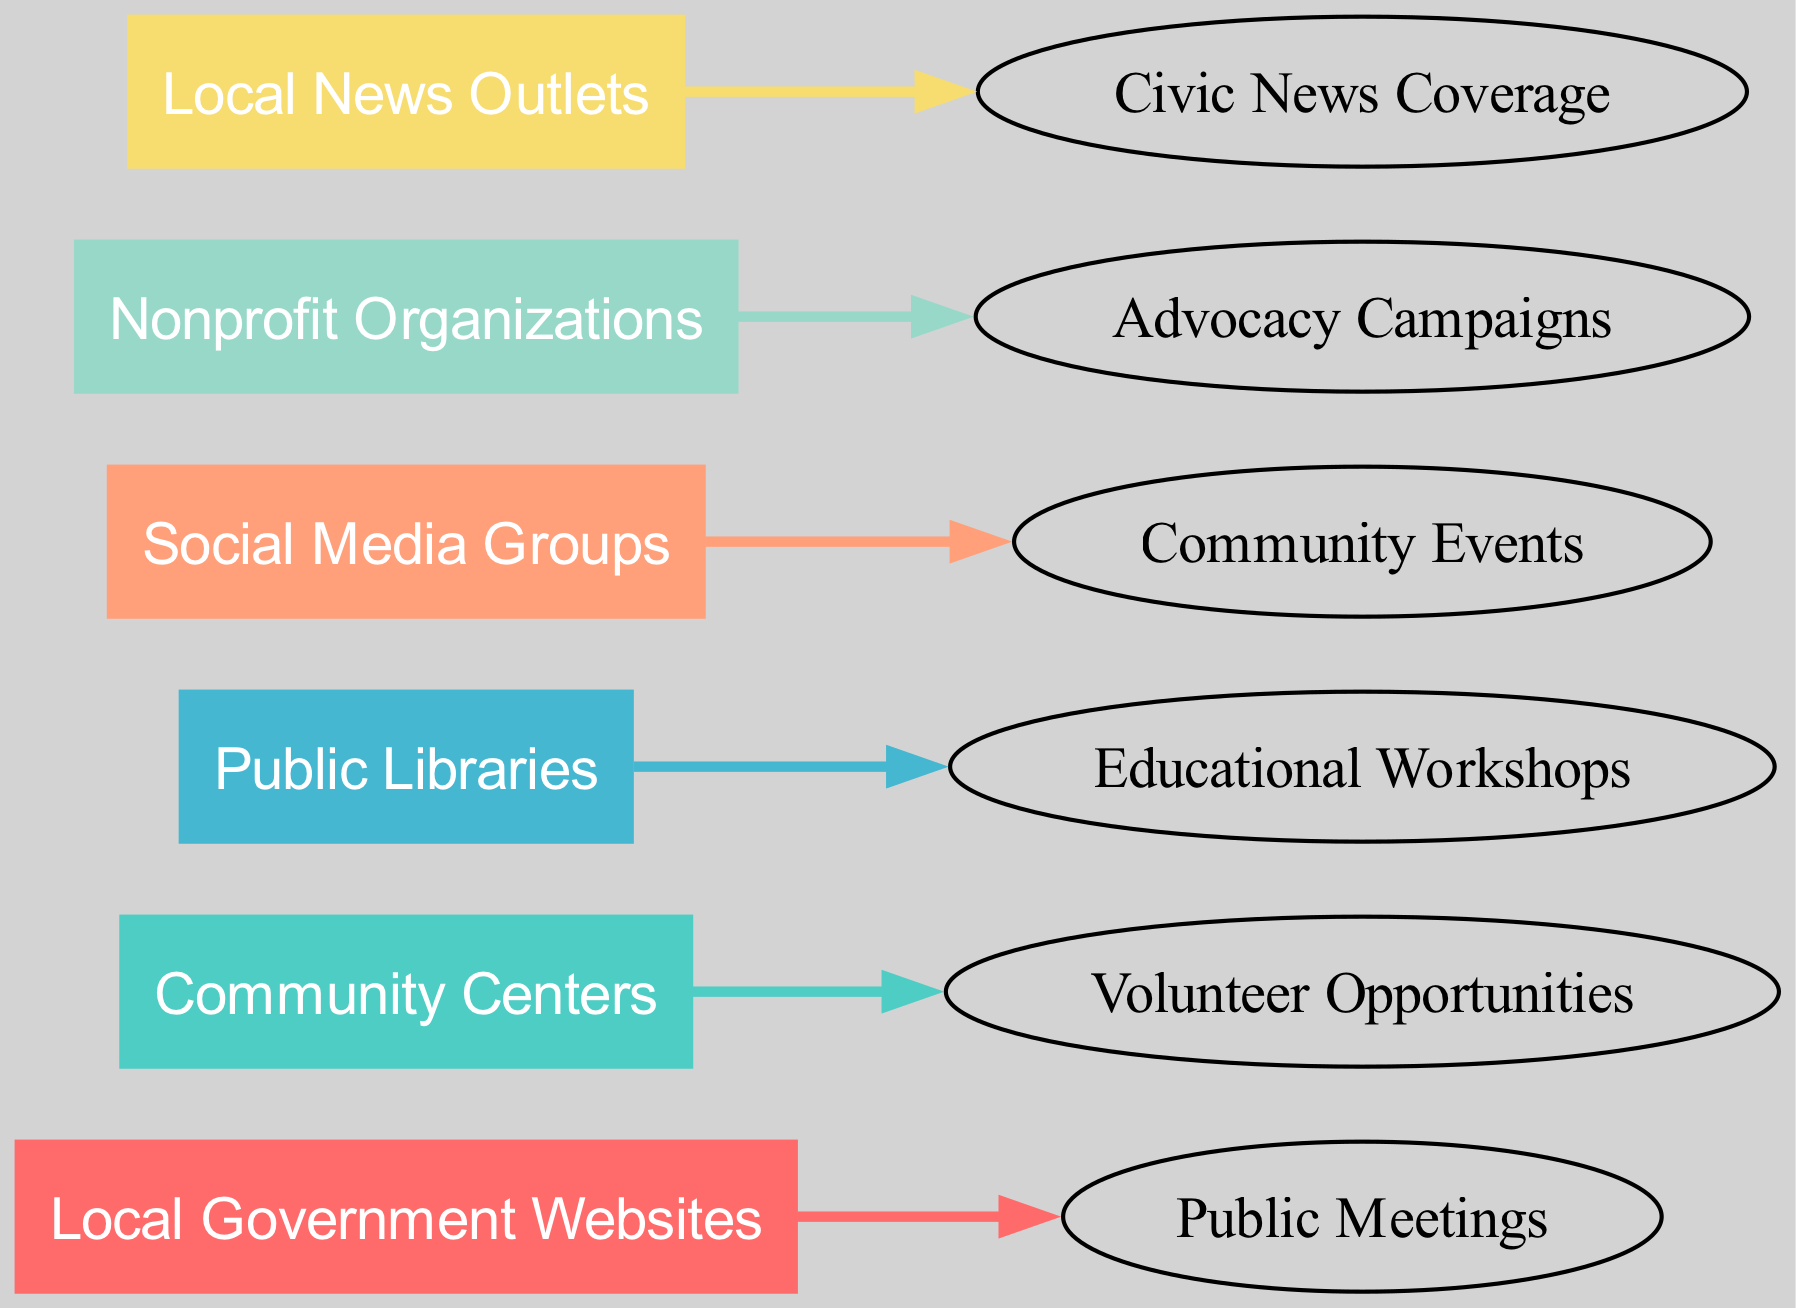What is the total number of sources in the diagram? The diagram lists six sources: Local Government Websites, Community Centers, Public Libraries, Social Media Groups, Nonprofit Organizations, and Local News Outlets. Adding them together gives a total of six sources.
Answer: 6 Which source leads to Public Meetings? By reviewing the connections in the diagram, I see that the arrow pointing towards Public Meetings originates from the source labeled Local Government Websites.
Answer: Local Government Websites How many unique targets are shown in the diagram? The targets identified are Public Meetings, Volunteer Opportunities, Educational Workshops, Community Events, Advocacy Campaigns, and Civic News Coverage. Counting these, I see there are six unique targets.
Answer: 6 Which source is associated with Volunteer Opportunities? Looking at the connections in the diagram, the line that connects to Volunteer Opportunities comes from the source called Community Centers.
Answer: Community Centers What relationship exists between Local News Outlets and Civic News Coverage? The diagram shows a direct connection emanating from Local News Outlets pointing directly to Civic News Coverage, indicating that this source provides that type of information.
Answer: Direct connection Which source contributes to Advocacy Campaigns? Inspecting the connections reveals that Nonprofit Organizations is the source that connects to Advocacy Campaigns in the diagram.
Answer: Nonprofit Organizations How many connections are there from the sources to the targets? The diagram indicates that there are six connections drawn from the six sources to their respective targets, each source leading to one target, resulting in six total connections.
Answer: 6 Which source has the least visually prominent color in the diagram? By observing the color assignments based on the provided code, the source that appears with a lighter pastel color compared to other sources is Social Media Groups, making it visually less prominent.
Answer: Social Media Groups What is the relationship pattern evident from the Community Centers source? The diagram shows that Community Centers exclusively connect to Volunteer Opportunities, indicating a specialized relationship where this source specifically focuses on a single type of engagement opportunity.
Answer: Exclusive to Volunteer Opportunities 